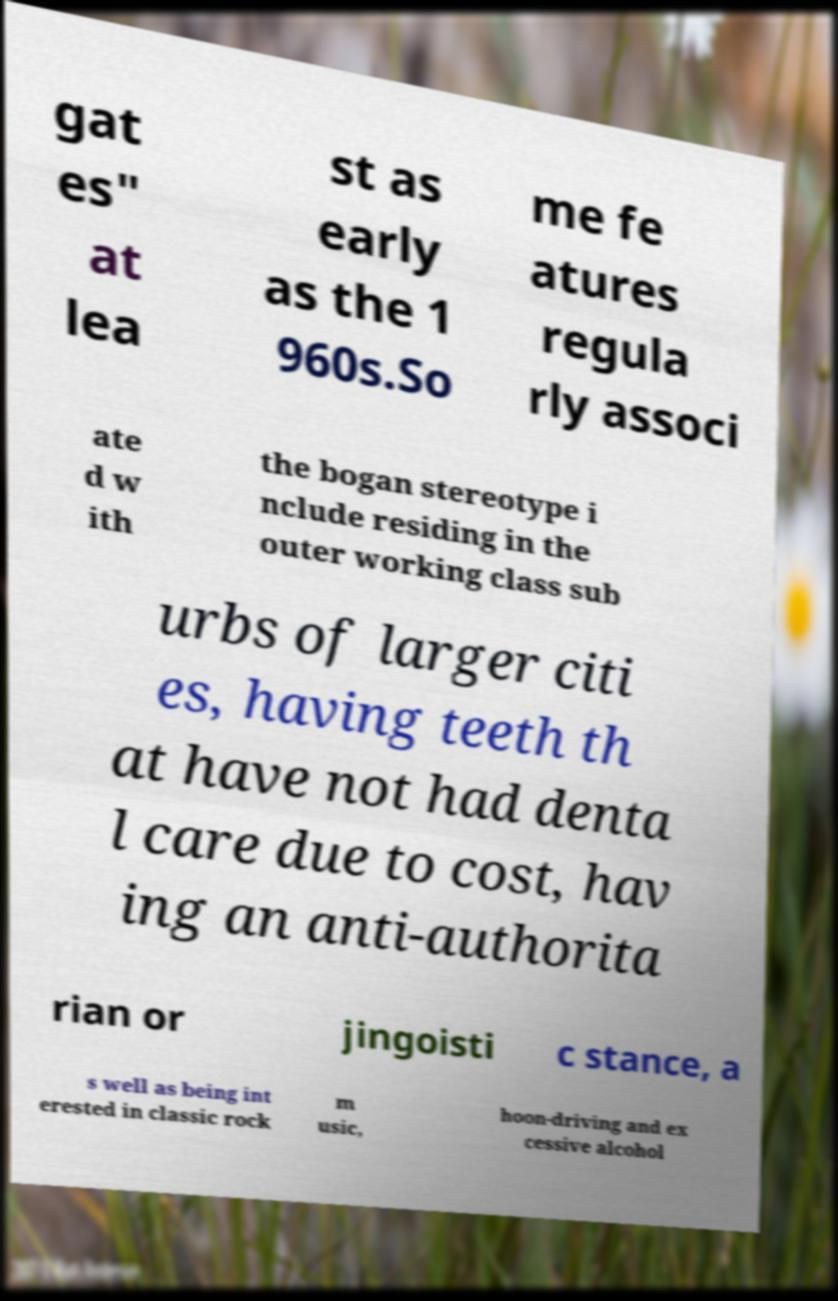Please read and relay the text visible in this image. What does it say? gat es" at lea st as early as the 1 960s.So me fe atures regula rly associ ate d w ith the bogan stereotype i nclude residing in the outer working class sub urbs of larger citi es, having teeth th at have not had denta l care due to cost, hav ing an anti-authorita rian or jingoisti c stance, a s well as being int erested in classic rock m usic, hoon-driving and ex cessive alcohol 